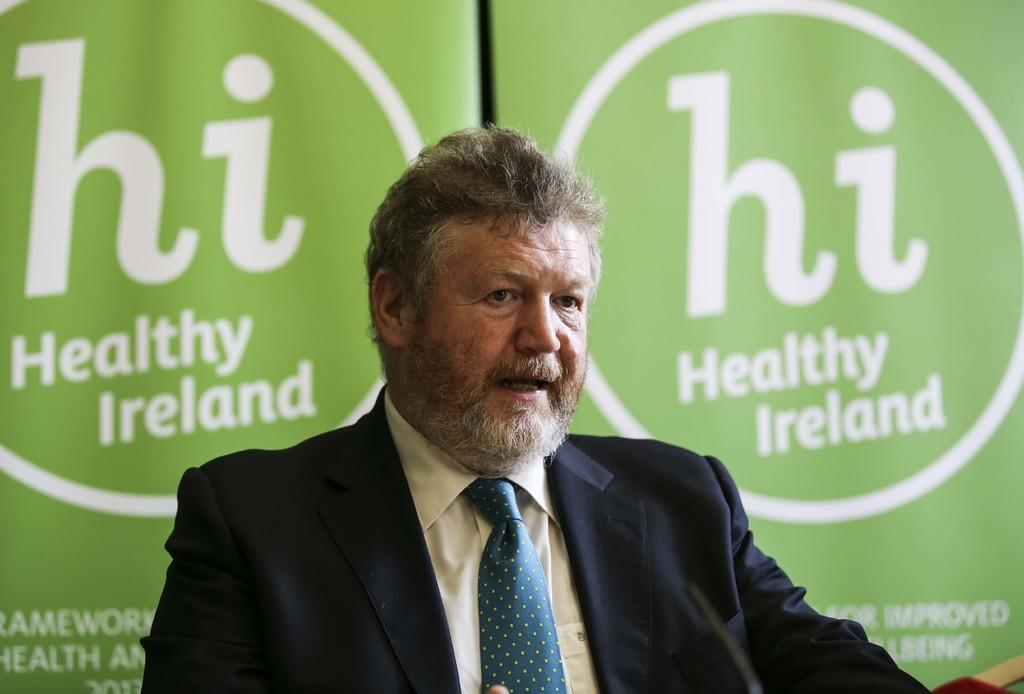What is the main subject of the image? There is a person in the image. What can be seen in the background of the image? There are banners with text in the background of the image. What type of notebook is being used by the person in the image? There is no notebook visible in the image. How many times does the person in the image bite their lip? There is no indication of the person biting their lip in the image. 